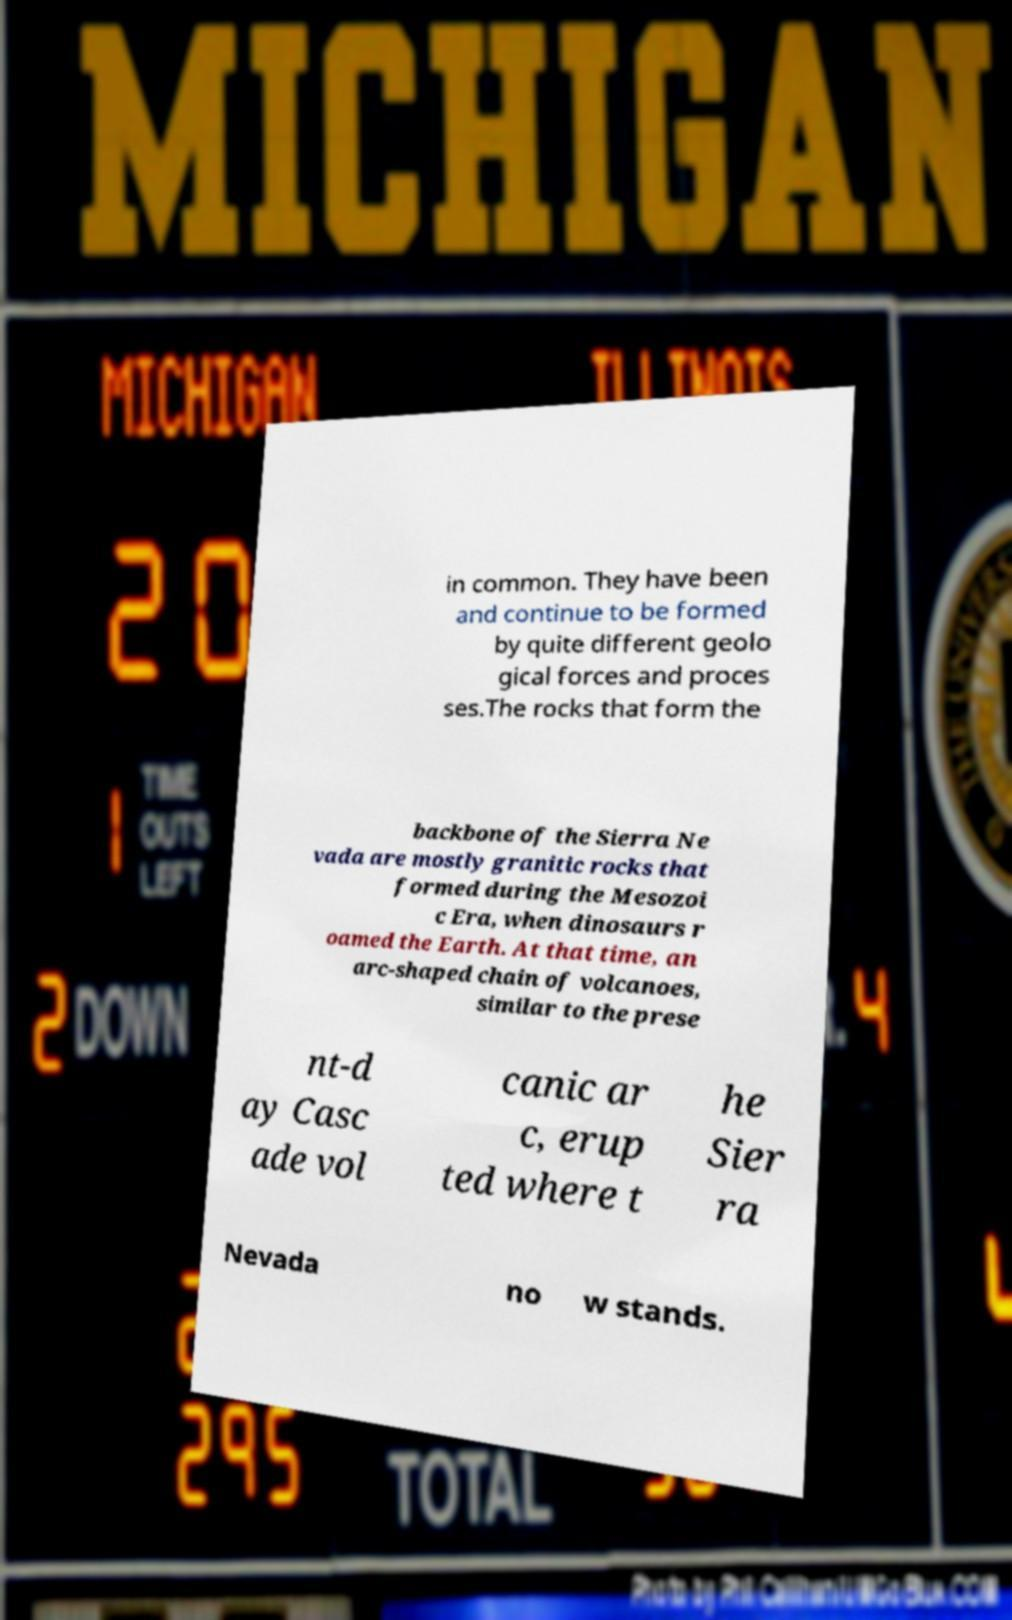Could you extract and type out the text from this image? in common. They have been and continue to be formed by quite different geolo gical forces and proces ses.The rocks that form the backbone of the Sierra Ne vada are mostly granitic rocks that formed during the Mesozoi c Era, when dinosaurs r oamed the Earth. At that time, an arc-shaped chain of volcanoes, similar to the prese nt-d ay Casc ade vol canic ar c, erup ted where t he Sier ra Nevada no w stands. 